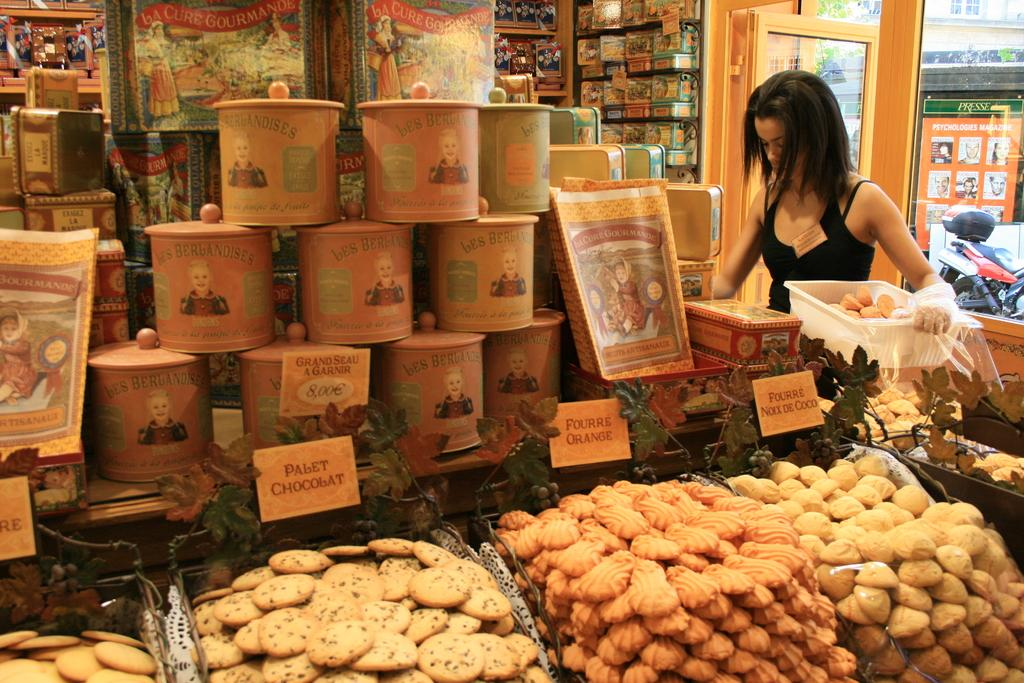<image>
Share a concise interpretation of the image provided. A women in an isle of a grocery store with bins of different cookies including some from bes BerbAndises. 